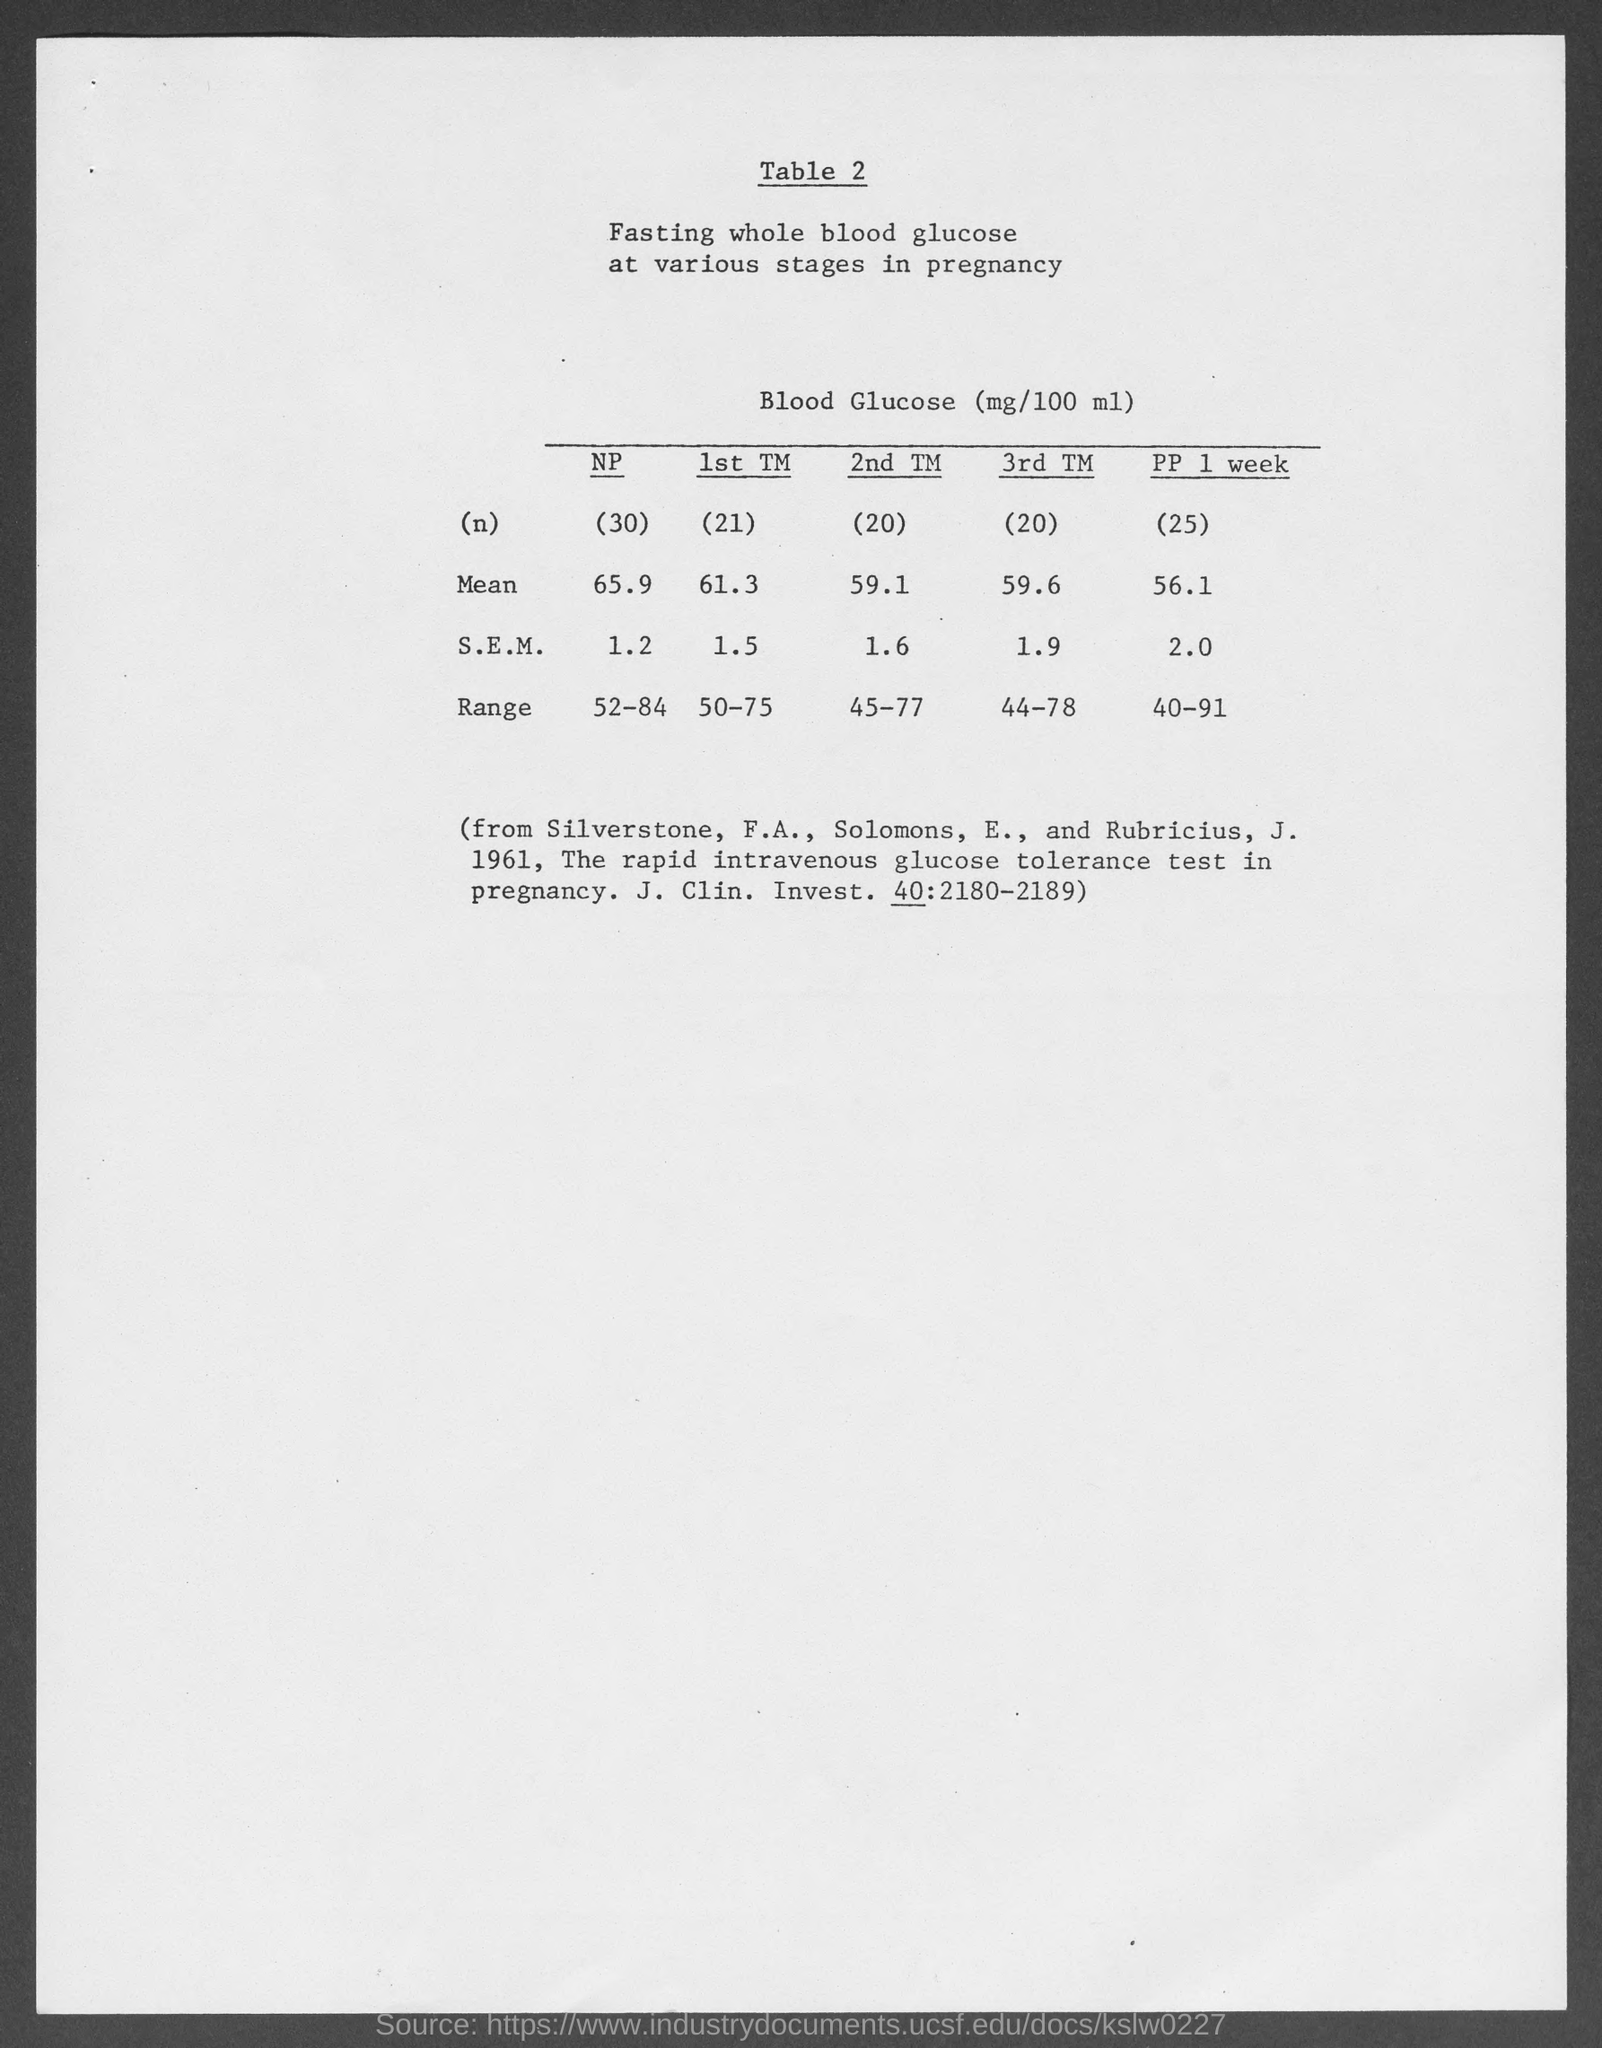What is the mean value of 1st TM?
Offer a very short reply. 61.3. What is the S.E.M value of 2nd TM ?
Give a very brief answer. 1.6. What is the mean value of 3rd TM?
Keep it short and to the point. 59.6. 